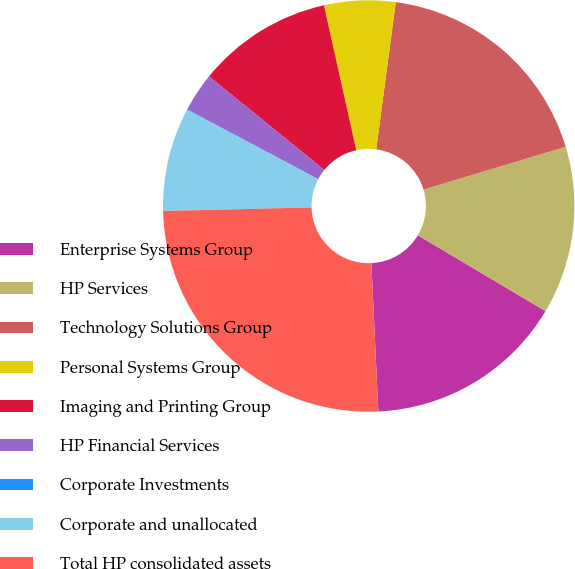Convert chart. <chart><loc_0><loc_0><loc_500><loc_500><pie_chart><fcel>Enterprise Systems Group<fcel>HP Services<fcel>Technology Solutions Group<fcel>Personal Systems Group<fcel>Imaging and Printing Group<fcel>HP Financial Services<fcel>Corporate Investments<fcel>Corporate and unallocated<fcel>Total HP consolidated assets<nl><fcel>15.72%<fcel>13.19%<fcel>18.25%<fcel>5.59%<fcel>10.66%<fcel>3.06%<fcel>0.05%<fcel>8.13%<fcel>25.36%<nl></chart> 